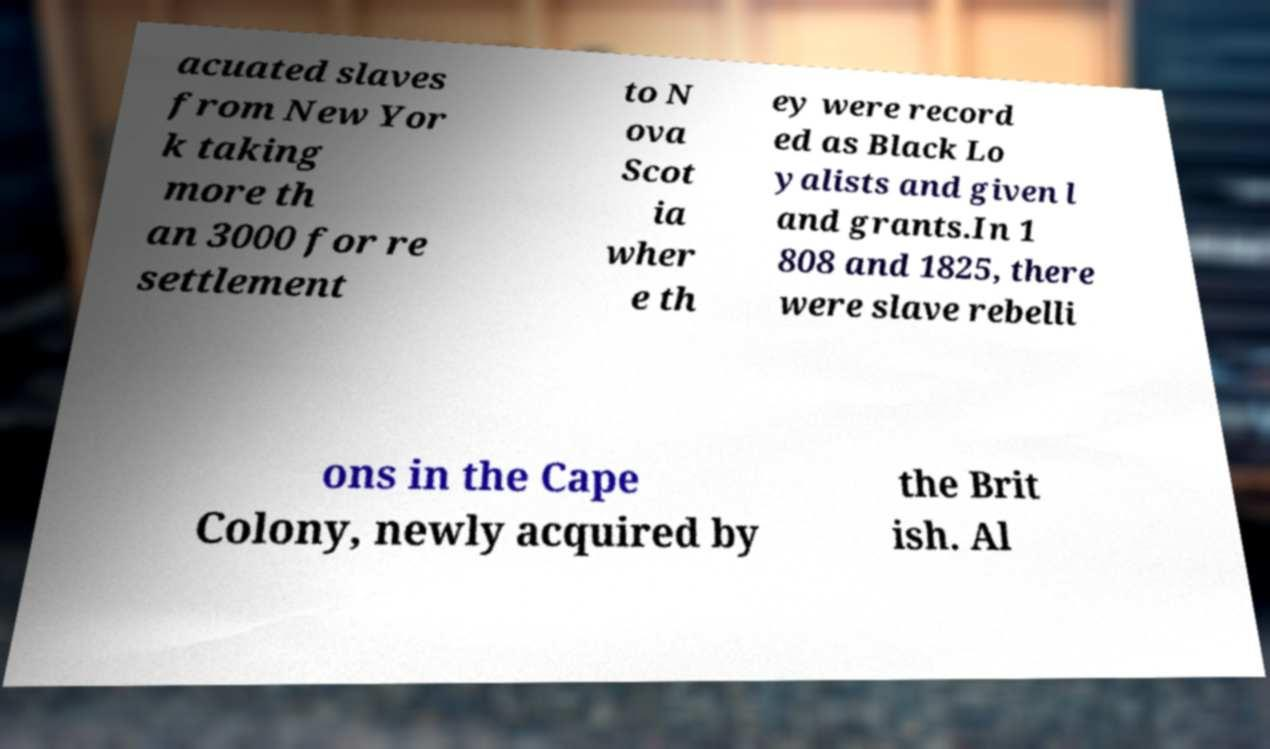What messages or text are displayed in this image? I need them in a readable, typed format. acuated slaves from New Yor k taking more th an 3000 for re settlement to N ova Scot ia wher e th ey were record ed as Black Lo yalists and given l and grants.In 1 808 and 1825, there were slave rebelli ons in the Cape Colony, newly acquired by the Brit ish. Al 